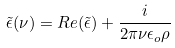Convert formula to latex. <formula><loc_0><loc_0><loc_500><loc_500>\tilde { \epsilon } ( \nu ) = R e ( \tilde { \epsilon } ) + \frac { i } { 2 \pi \nu \epsilon _ { o } \rho }</formula> 